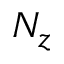Convert formula to latex. <formula><loc_0><loc_0><loc_500><loc_500>N _ { z }</formula> 